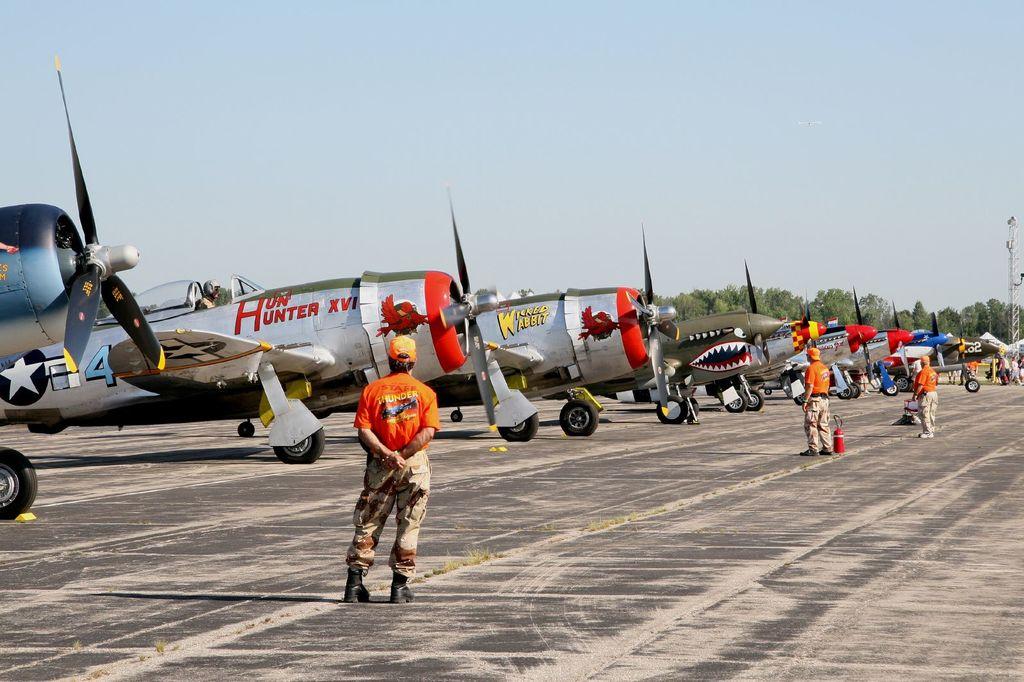What is the plane name written in red?
Your response must be concise. Hunter. What is the blue number all the way to the left?
Your answer should be very brief. 4. 